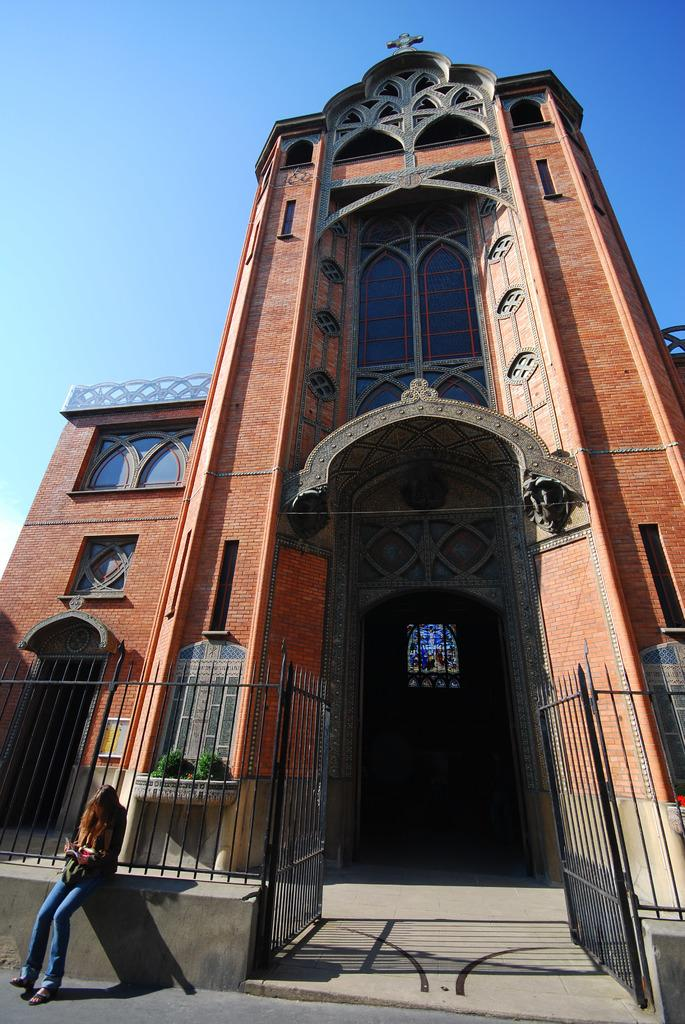What type of building is shown in the image? The image is of an entrance view of a Church building. Can you describe the woman's position in the image? There is a woman sitting on a concrete platform in front of the Church building. What type of prose can be heard being read by the woman in the image? There is no indication in the image that the woman is reading or speaking any prose, so it cannot be determined from the picture. 